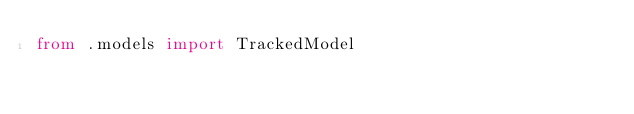Convert code to text. <code><loc_0><loc_0><loc_500><loc_500><_Python_>from .models import TrackedModel
</code> 